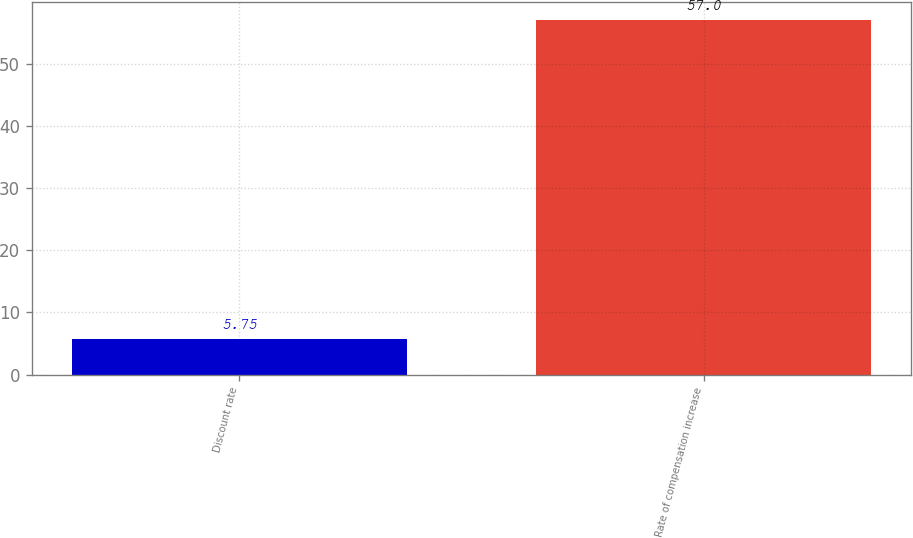<chart> <loc_0><loc_0><loc_500><loc_500><bar_chart><fcel>Discount rate<fcel>Rate of compensation increase<nl><fcel>5.75<fcel>57<nl></chart> 